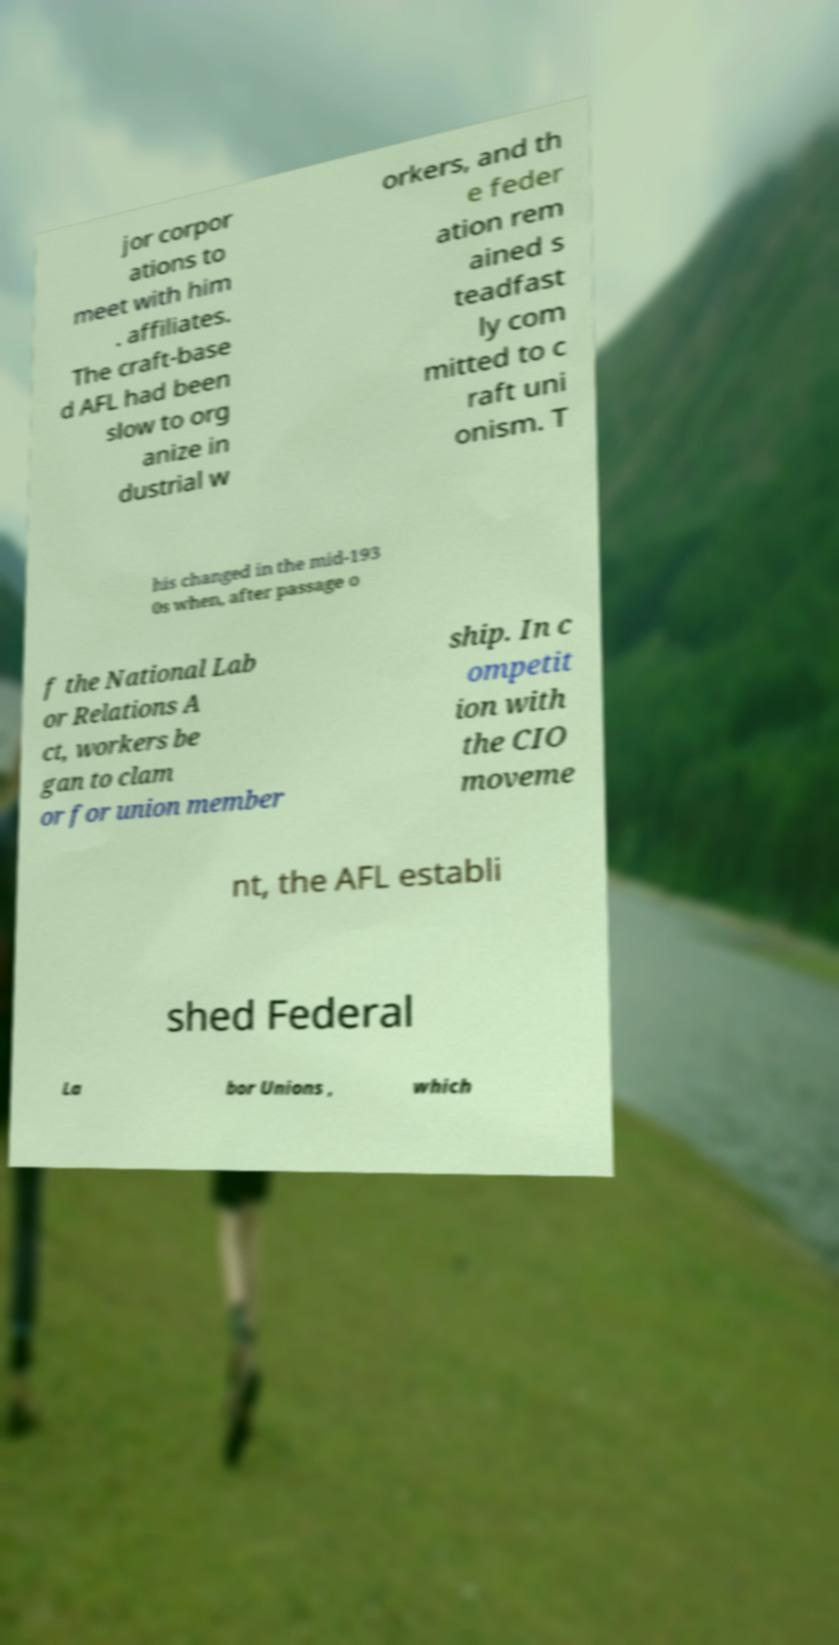Could you assist in decoding the text presented in this image and type it out clearly? jor corpor ations to meet with him . affiliates. The craft-base d AFL had been slow to org anize in dustrial w orkers, and th e feder ation rem ained s teadfast ly com mitted to c raft uni onism. T his changed in the mid-193 0s when, after passage o f the National Lab or Relations A ct, workers be gan to clam or for union member ship. In c ompetit ion with the CIO moveme nt, the AFL establi shed Federal La bor Unions , which 